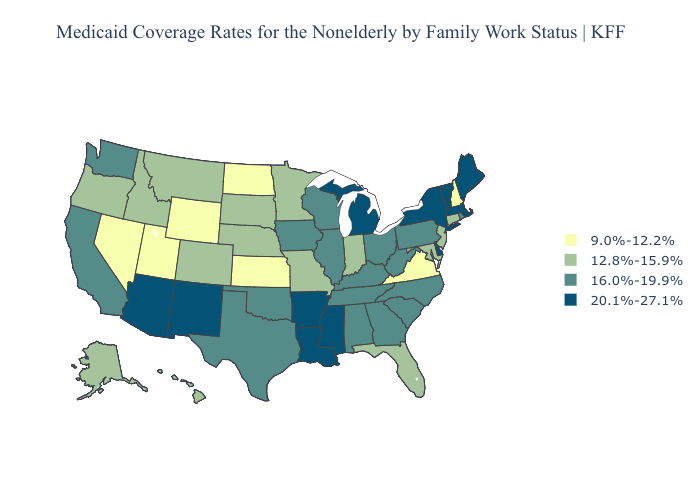Name the states that have a value in the range 20.1%-27.1%?
Quick response, please. Arizona, Arkansas, Delaware, Louisiana, Maine, Massachusetts, Michigan, Mississippi, New Mexico, New York, Vermont. What is the value of Kentucky?
Keep it brief. 16.0%-19.9%. Does New York have the highest value in the Northeast?
Concise answer only. Yes. Does New Jersey have the lowest value in the USA?
Answer briefly. No. What is the value of Tennessee?
Short answer required. 16.0%-19.9%. Does the first symbol in the legend represent the smallest category?
Write a very short answer. Yes. Which states have the lowest value in the MidWest?
Be succinct. Kansas, North Dakota. What is the value of Missouri?
Give a very brief answer. 12.8%-15.9%. Which states have the lowest value in the USA?
Concise answer only. Kansas, Nevada, New Hampshire, North Dakota, Utah, Virginia, Wyoming. Name the states that have a value in the range 9.0%-12.2%?
Write a very short answer. Kansas, Nevada, New Hampshire, North Dakota, Utah, Virginia, Wyoming. Name the states that have a value in the range 16.0%-19.9%?
Keep it brief. Alabama, California, Georgia, Illinois, Iowa, Kentucky, North Carolina, Ohio, Oklahoma, Pennsylvania, Rhode Island, South Carolina, Tennessee, Texas, Washington, West Virginia, Wisconsin. What is the value of Oklahoma?
Be succinct. 16.0%-19.9%. What is the highest value in states that border Nebraska?
Give a very brief answer. 16.0%-19.9%. What is the lowest value in the South?
Short answer required. 9.0%-12.2%. Among the states that border New Hampshire , which have the highest value?
Write a very short answer. Maine, Massachusetts, Vermont. 